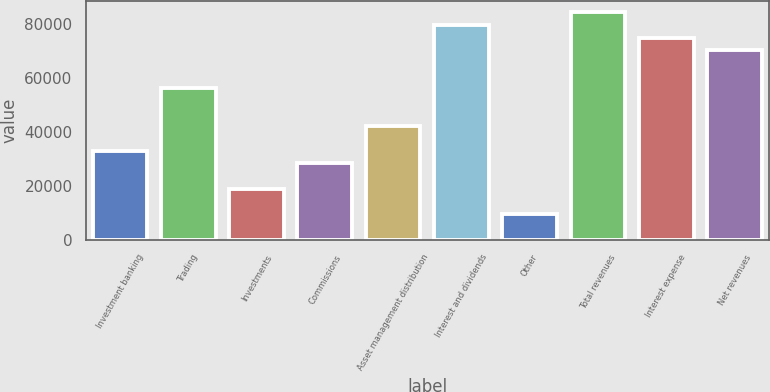Convert chart to OTSL. <chart><loc_0><loc_0><loc_500><loc_500><bar_chart><fcel>Investment banking<fcel>Trading<fcel>Investments<fcel>Commissions<fcel>Asset management distribution<fcel>Interest and dividends<fcel>Other<fcel>Total revenues<fcel>Interest expense<fcel>Net revenues<nl><fcel>33047.2<fcel>56430.2<fcel>19017.4<fcel>28370.6<fcel>42400.4<fcel>79813.2<fcel>9664.2<fcel>84489.8<fcel>75136.6<fcel>70460<nl></chart> 